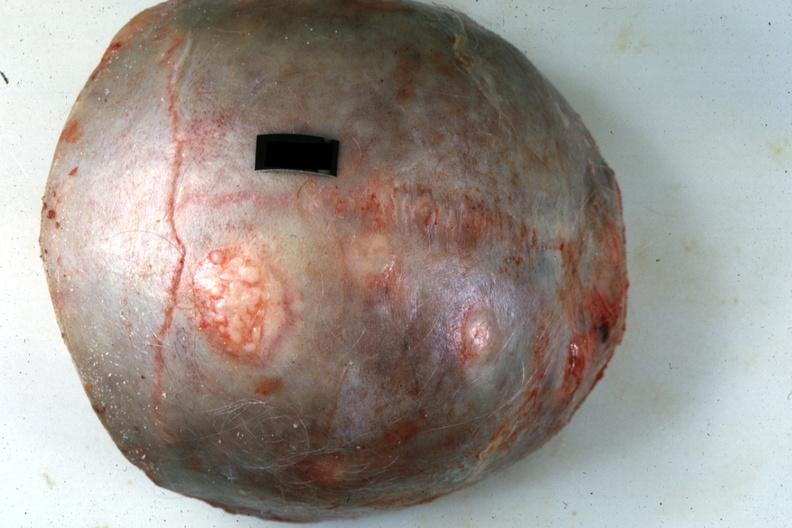s metastatic pancreas carcinoma present?
Answer the question using a single word or phrase. Yes 